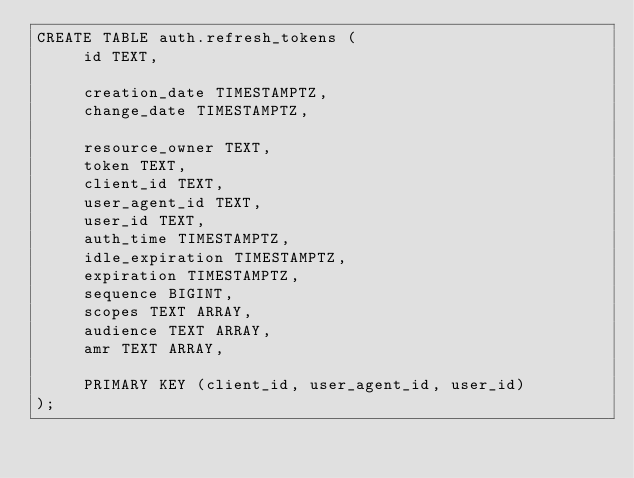Convert code to text. <code><loc_0><loc_0><loc_500><loc_500><_SQL_>CREATE TABLE auth.refresh_tokens (
     id TEXT,

     creation_date TIMESTAMPTZ,
     change_date TIMESTAMPTZ,

     resource_owner TEXT,
     token TEXT,
     client_id TEXT,
     user_agent_id TEXT,
     user_id TEXT,
     auth_time TIMESTAMPTZ,
     idle_expiration TIMESTAMPTZ,
     expiration TIMESTAMPTZ,
     sequence BIGINT,
     scopes TEXT ARRAY,
     audience TEXT ARRAY,
     amr TEXT ARRAY,

     PRIMARY KEY (client_id, user_agent_id, user_id)
);
</code> 